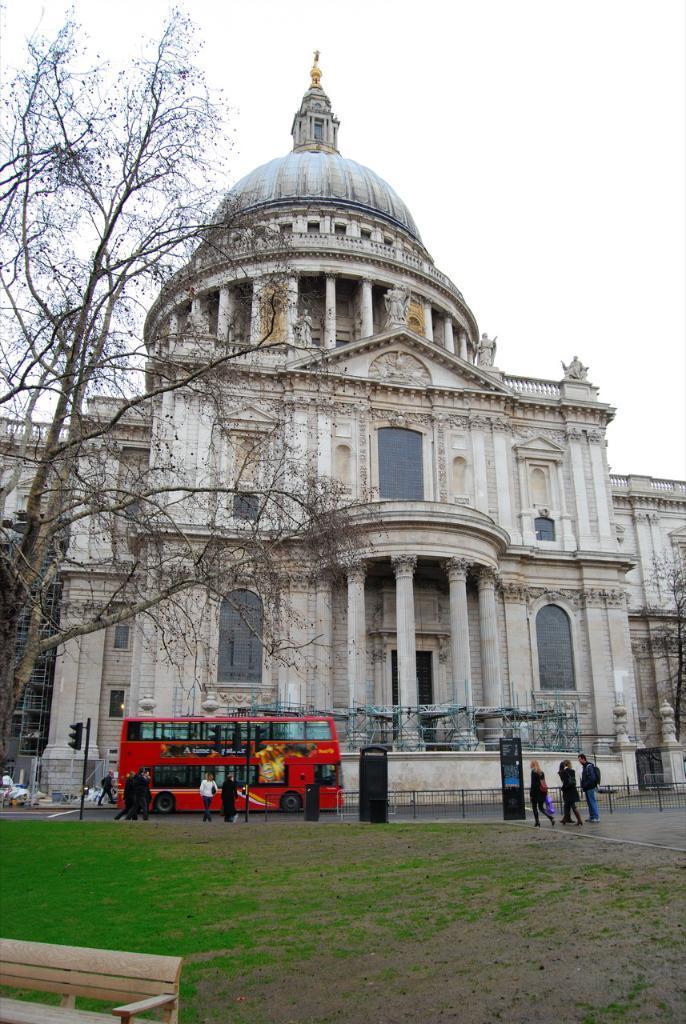Can you describe this image briefly? In this image there is a building, trees, vehicle, people, grass, bench, signal light pole, board, railing, sky and objects. 